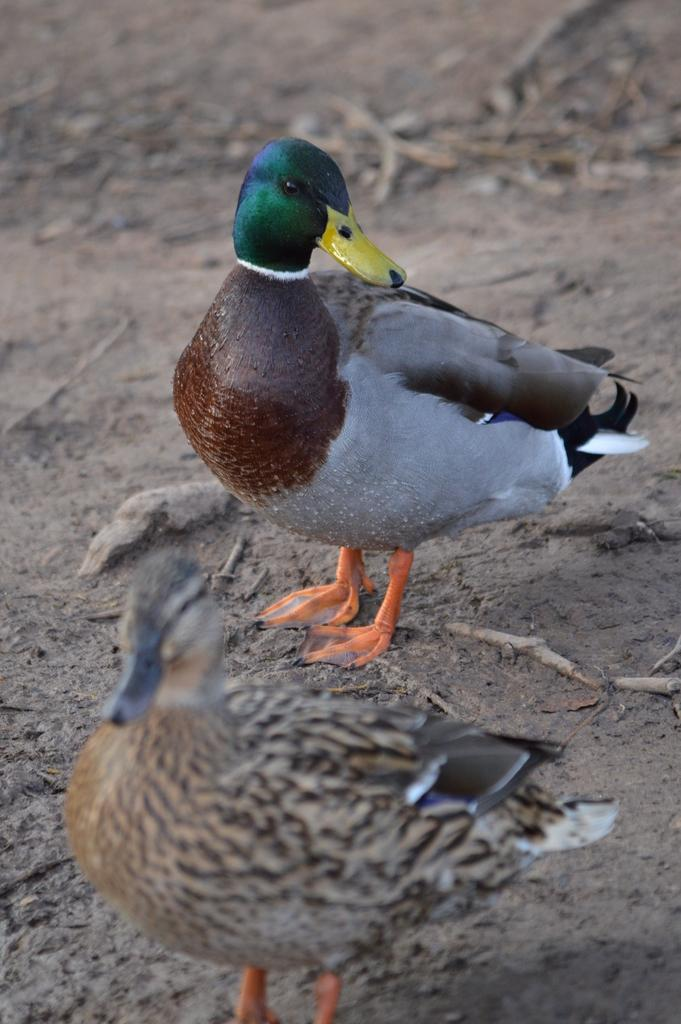How many birds are present in the image? There are two birds in the image. What are the birds doing in the image? The birds are standing on the ground in the image. Can you describe the birds' positions relative to each other? The birds are beside each other in the image. What type of terrain is visible in the image? There is sand on the ground in the image, and there are also small dry sticks present. What type of vessel is being used by the birds in the image? There is no vessel present in the image; the birds are standing on the ground. What day of the week is depicted in the image? The image does not depict a specific day of the week; it only shows the birds and their surroundings. 